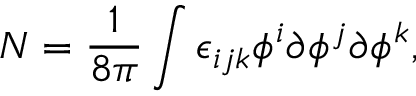Convert formula to latex. <formula><loc_0><loc_0><loc_500><loc_500>N = \frac { 1 } { 8 \pi } \int \epsilon _ { i j k } \phi ^ { i } \partial \phi ^ { j } \partial \phi ^ { k } ,</formula> 